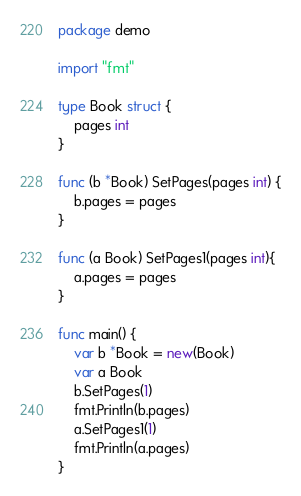Convert code to text. <code><loc_0><loc_0><loc_500><loc_500><_Go_>package demo

import "fmt"

type Book struct {
	pages int
}

func (b *Book) SetPages(pages int) {
	b.pages = pages
}

func (a Book) SetPages1(pages int){
	a.pages = pages
}

func main() {
	var b *Book = new(Book)
	var a Book
	b.SetPages(1)
	fmt.Println(b.pages)
	a.SetPages1(1)
	fmt.Println(a.pages)
}</code> 